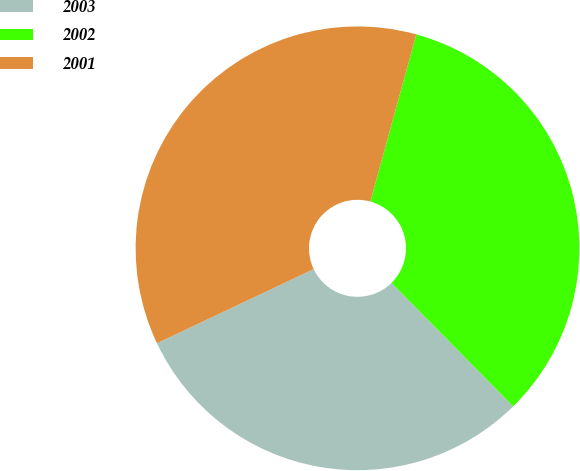Convert chart. <chart><loc_0><loc_0><loc_500><loc_500><pie_chart><fcel>2003<fcel>2002<fcel>2001<nl><fcel>30.34%<fcel>33.35%<fcel>36.3%<nl></chart> 